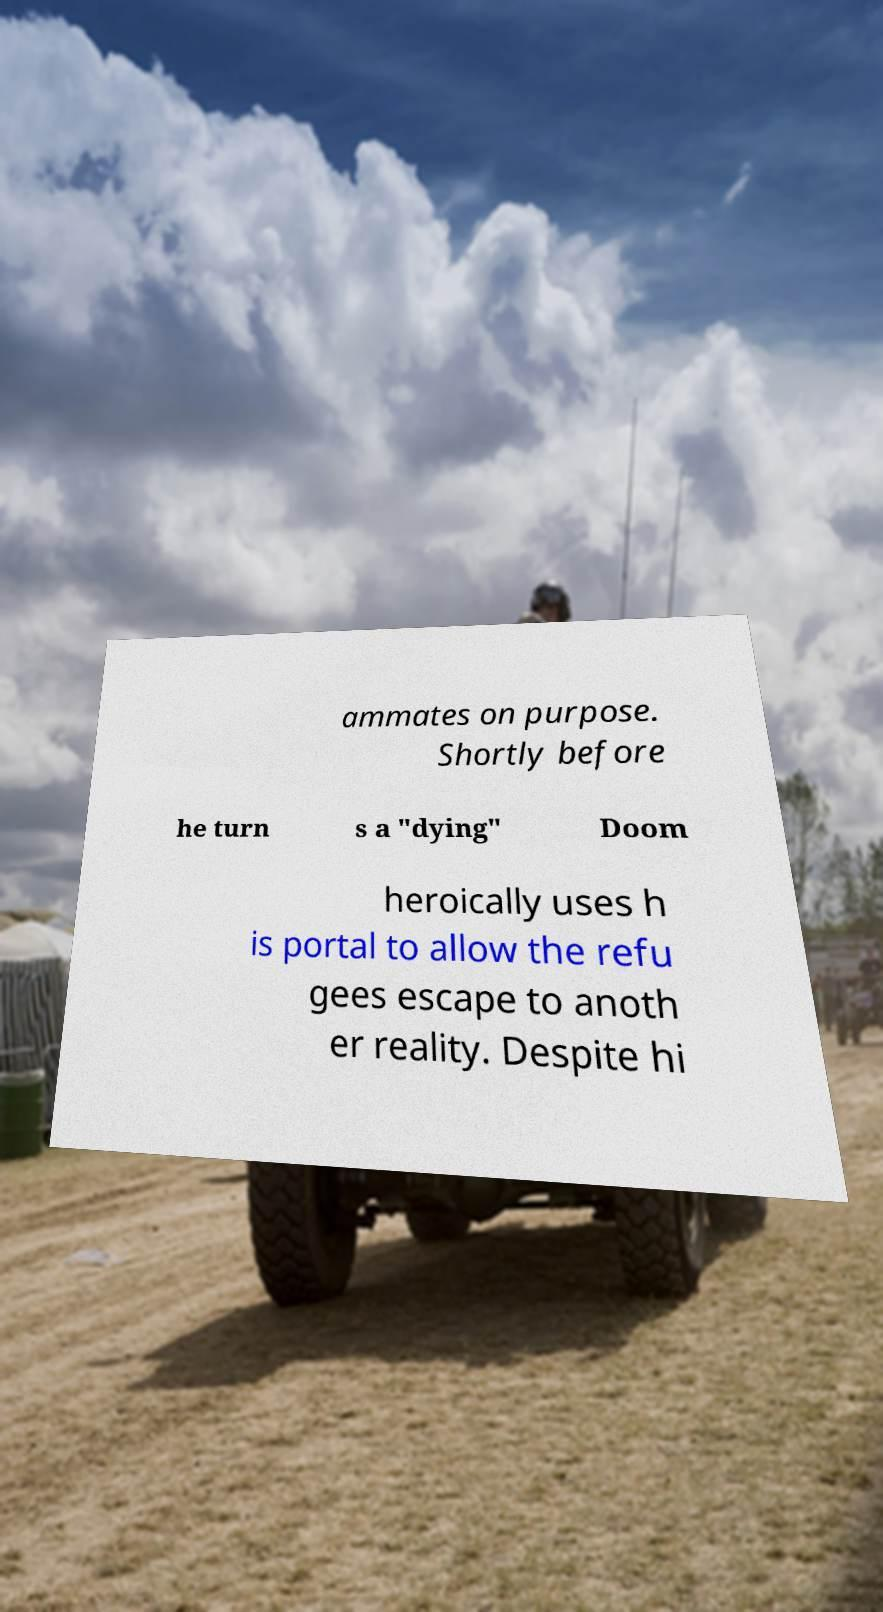I need the written content from this picture converted into text. Can you do that? ammates on purpose. Shortly before he turn s a "dying" Doom heroically uses h is portal to allow the refu gees escape to anoth er reality. Despite hi 